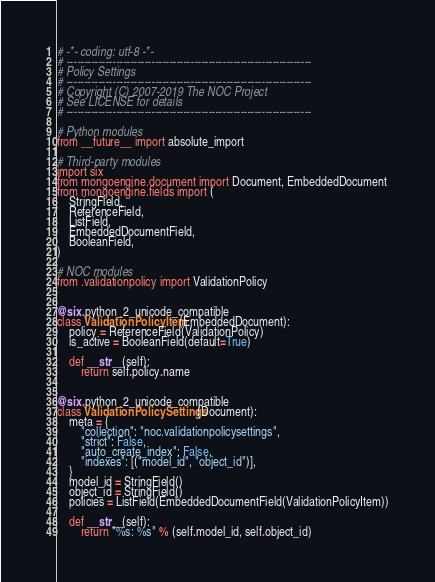Convert code to text. <code><loc_0><loc_0><loc_500><loc_500><_Python_># -*- coding: utf-8 -*-
# ---------------------------------------------------------------------
# Policy Settings
# ---------------------------------------------------------------------
# Copyright (C) 2007-2019 The NOC Project
# See LICENSE for details
# ---------------------------------------------------------------------

# Python modules
from __future__ import absolute_import

# Third-party modules
import six
from mongoengine.document import Document, EmbeddedDocument
from mongoengine.fields import (
    StringField,
    ReferenceField,
    ListField,
    EmbeddedDocumentField,
    BooleanField,
)

# NOC modules
from .validationpolicy import ValidationPolicy


@six.python_2_unicode_compatible
class ValidationPolicyItem(EmbeddedDocument):
    policy = ReferenceField(ValidationPolicy)
    is_active = BooleanField(default=True)

    def __str__(self):
        return self.policy.name


@six.python_2_unicode_compatible
class ValidationPolicySettings(Document):
    meta = {
        "collection": "noc.validationpolicysettings",
        "strict": False,
        "auto_create_index": False,
        "indexes": [("model_id", "object_id")],
    }
    model_id = StringField()
    object_id = StringField()
    policies = ListField(EmbeddedDocumentField(ValidationPolicyItem))

    def __str__(self):
        return "%s: %s" % (self.model_id, self.object_id)
</code> 